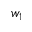Convert formula to latex. <formula><loc_0><loc_0><loc_500><loc_500>w _ { 1 }</formula> 